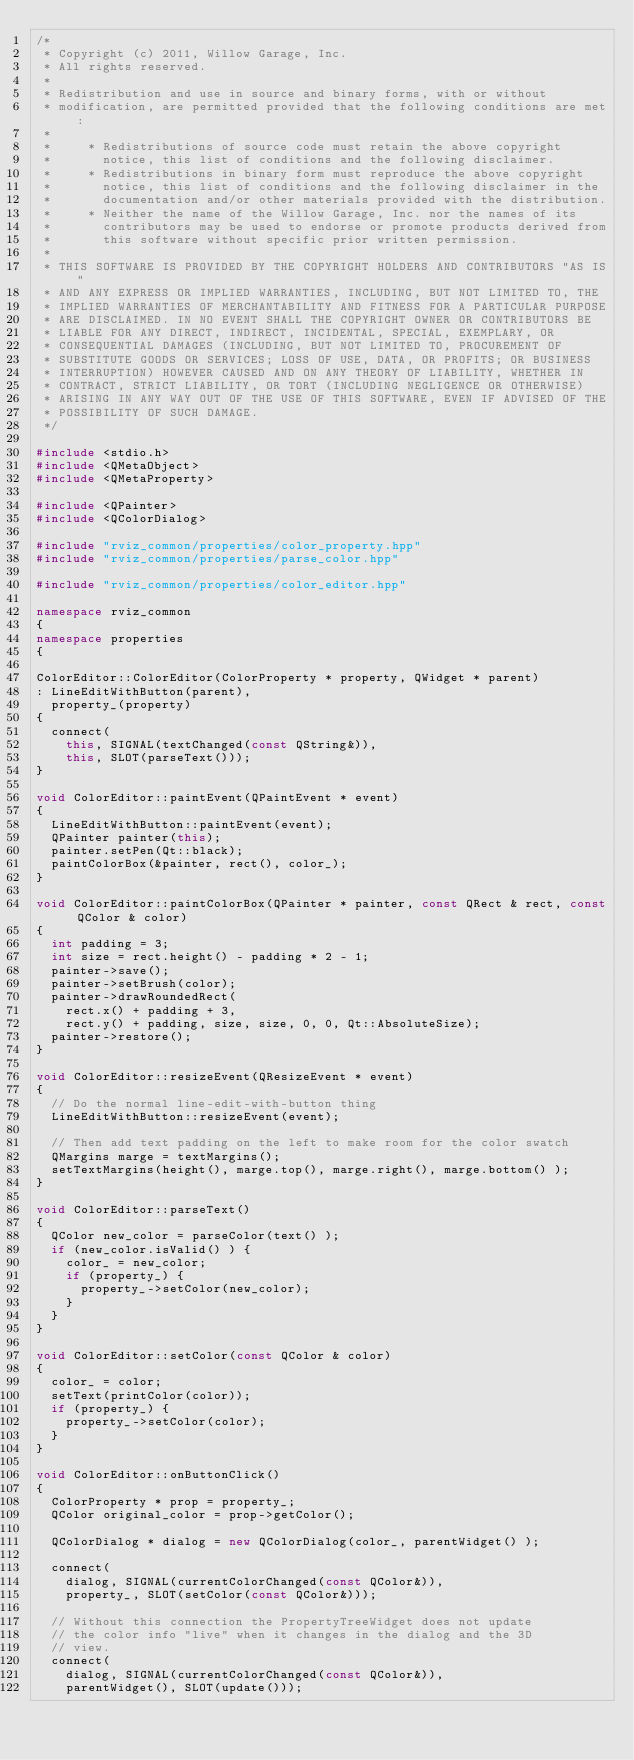<code> <loc_0><loc_0><loc_500><loc_500><_C++_>/*
 * Copyright (c) 2011, Willow Garage, Inc.
 * All rights reserved.
 *
 * Redistribution and use in source and binary forms, with or without
 * modification, are permitted provided that the following conditions are met:
 *
 *     * Redistributions of source code must retain the above copyright
 *       notice, this list of conditions and the following disclaimer.
 *     * Redistributions in binary form must reproduce the above copyright
 *       notice, this list of conditions and the following disclaimer in the
 *       documentation and/or other materials provided with the distribution.
 *     * Neither the name of the Willow Garage, Inc. nor the names of its
 *       contributors may be used to endorse or promote products derived from
 *       this software without specific prior written permission.
 *
 * THIS SOFTWARE IS PROVIDED BY THE COPYRIGHT HOLDERS AND CONTRIBUTORS "AS IS"
 * AND ANY EXPRESS OR IMPLIED WARRANTIES, INCLUDING, BUT NOT LIMITED TO, THE
 * IMPLIED WARRANTIES OF MERCHANTABILITY AND FITNESS FOR A PARTICULAR PURPOSE
 * ARE DISCLAIMED. IN NO EVENT SHALL THE COPYRIGHT OWNER OR CONTRIBUTORS BE
 * LIABLE FOR ANY DIRECT, INDIRECT, INCIDENTAL, SPECIAL, EXEMPLARY, OR
 * CONSEQUENTIAL DAMAGES (INCLUDING, BUT NOT LIMITED TO, PROCUREMENT OF
 * SUBSTITUTE GOODS OR SERVICES; LOSS OF USE, DATA, OR PROFITS; OR BUSINESS
 * INTERRUPTION) HOWEVER CAUSED AND ON ANY THEORY OF LIABILITY, WHETHER IN
 * CONTRACT, STRICT LIABILITY, OR TORT (INCLUDING NEGLIGENCE OR OTHERWISE)
 * ARISING IN ANY WAY OUT OF THE USE OF THIS SOFTWARE, EVEN IF ADVISED OF THE
 * POSSIBILITY OF SUCH DAMAGE.
 */

#include <stdio.h>
#include <QMetaObject>
#include <QMetaProperty>

#include <QPainter>
#include <QColorDialog>

#include "rviz_common/properties/color_property.hpp"
#include "rviz_common/properties/parse_color.hpp"

#include "rviz_common/properties/color_editor.hpp"

namespace rviz_common
{
namespace properties
{

ColorEditor::ColorEditor(ColorProperty * property, QWidget * parent)
: LineEditWithButton(parent),
  property_(property)
{
  connect(
    this, SIGNAL(textChanged(const QString&)),
    this, SLOT(parseText()));
}

void ColorEditor::paintEvent(QPaintEvent * event)
{
  LineEditWithButton::paintEvent(event);
  QPainter painter(this);
  painter.setPen(Qt::black);
  paintColorBox(&painter, rect(), color_);
}

void ColorEditor::paintColorBox(QPainter * painter, const QRect & rect, const QColor & color)
{
  int padding = 3;
  int size = rect.height() - padding * 2 - 1;
  painter->save();
  painter->setBrush(color);
  painter->drawRoundedRect(
    rect.x() + padding + 3,
    rect.y() + padding, size, size, 0, 0, Qt::AbsoluteSize);
  painter->restore();
}

void ColorEditor::resizeEvent(QResizeEvent * event)
{
  // Do the normal line-edit-with-button thing
  LineEditWithButton::resizeEvent(event);

  // Then add text padding on the left to make room for the color swatch
  QMargins marge = textMargins();
  setTextMargins(height(), marge.top(), marge.right(), marge.bottom() );
}

void ColorEditor::parseText()
{
  QColor new_color = parseColor(text() );
  if (new_color.isValid() ) {
    color_ = new_color;
    if (property_) {
      property_->setColor(new_color);
    }
  }
}

void ColorEditor::setColor(const QColor & color)
{
  color_ = color;
  setText(printColor(color));
  if (property_) {
    property_->setColor(color);
  }
}

void ColorEditor::onButtonClick()
{
  ColorProperty * prop = property_;
  QColor original_color = prop->getColor();

  QColorDialog * dialog = new QColorDialog(color_, parentWidget() );

  connect(
    dialog, SIGNAL(currentColorChanged(const QColor&)),
    property_, SLOT(setColor(const QColor&)));

  // Without this connection the PropertyTreeWidget does not update
  // the color info "live" when it changes in the dialog and the 3D
  // view.
  connect(
    dialog, SIGNAL(currentColorChanged(const QColor&)),
    parentWidget(), SLOT(update()));
</code> 